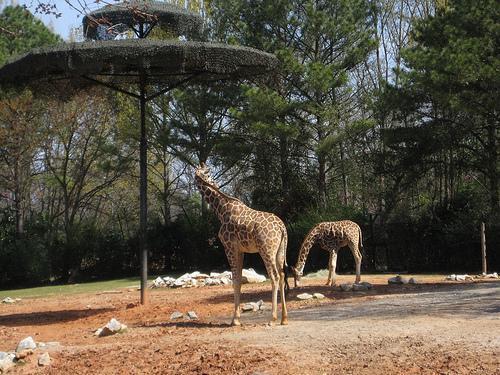How many giraffes are there?
Give a very brief answer. 2. How many baby giraffes are there?
Give a very brief answer. 1. How many giraffes are in the picture?
Give a very brief answer. 2. How many giraffes are eating?
Give a very brief answer. 1. How many giraffes are pictured?
Give a very brief answer. 2. 